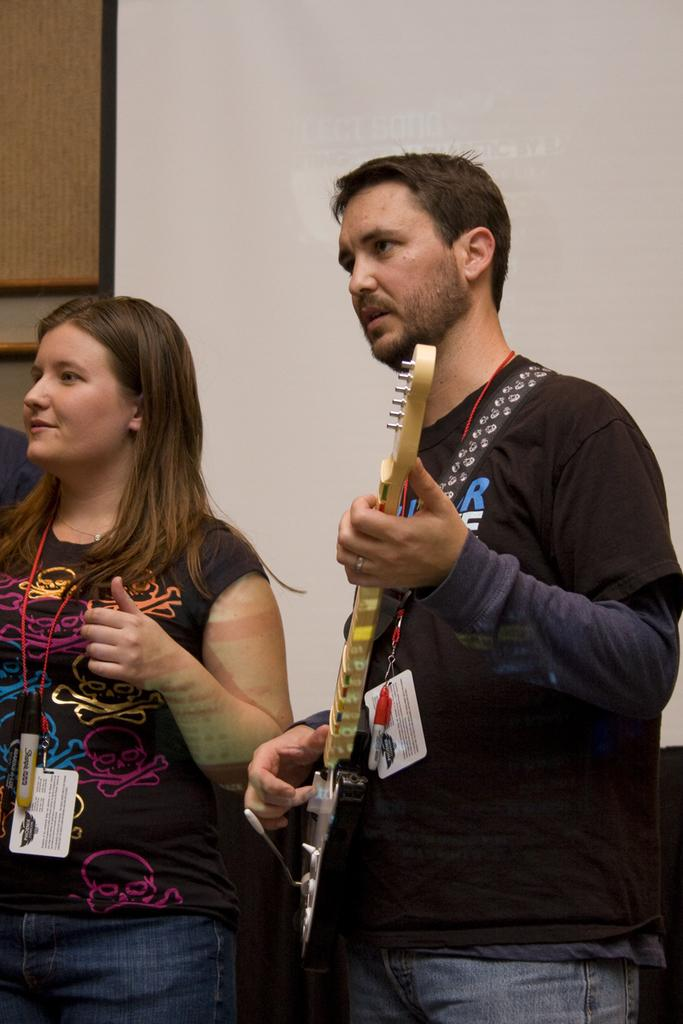How many people are in the image? There are two people in the image. Can you describe one of the people in the image? One of the people is a man. What is the man holding in the image? The man is holding a guitar. Is the man in the image wearing a cap? There is no mention of a cap in the image, so it cannot be determined whether the man is wearing one or not. 